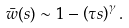Convert formula to latex. <formula><loc_0><loc_0><loc_500><loc_500>\bar { w } ( s ) \sim 1 - \left ( \tau s \right ) ^ { \gamma } .</formula> 